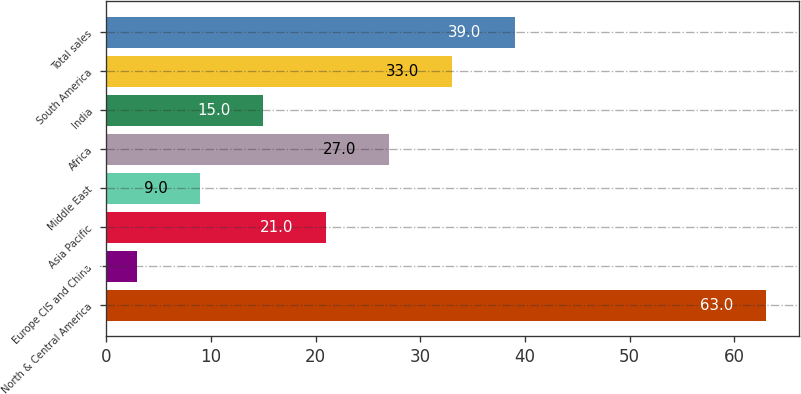<chart> <loc_0><loc_0><loc_500><loc_500><bar_chart><fcel>North & Central America<fcel>Europe CIS and China<fcel>Asia Pacific<fcel>Middle East<fcel>Africa<fcel>India<fcel>South America<fcel>Total sales<nl><fcel>63<fcel>3<fcel>21<fcel>9<fcel>27<fcel>15<fcel>33<fcel>39<nl></chart> 